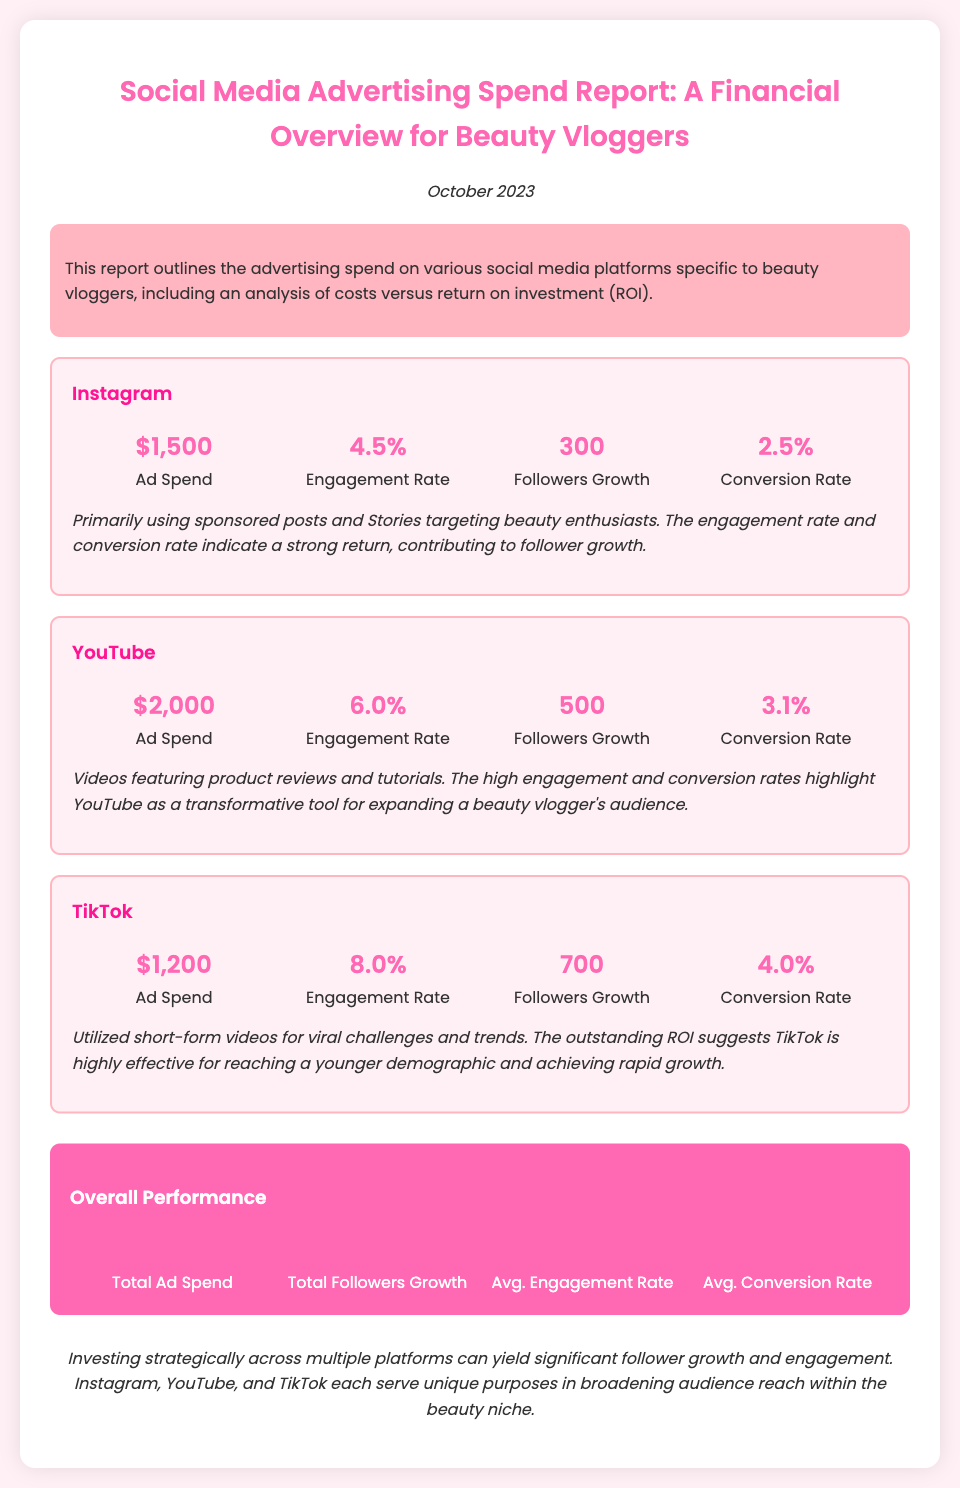What is the ad spend for Instagram? The ad spend for Instagram is explicitly stated in the document as $1,500.
Answer: $1,500 What is the engagement rate for TikTok? The engagement rate for TikTok is listed in the document as 8.0%.
Answer: 8.0% How much did YouTube ad spend total? The total ad spend for YouTube as mentioned in the report is $2,000.
Answer: $2,000 What is the total followers growth across all platforms? The total followers growth is summarized in the document as 1,500 across all platforms.
Answer: 1,500 What is the average conversion rate for all platforms? The document provides the average conversion rate as 3.20%.
Answer: 3.20% Which platform had the highest engagement rate? The highest engagement rate calculated from the data is for TikTok at 8.0%.
Answer: TikTok What was the primary method of advertisement on Instagram? The document notes that sponsored posts and Stories were the primary methods for Instagram.
Answer: Sponsored posts and Stories What conclusion is drawn about investing in multiple platforms? The document concludes that strategic investment across platforms yields significant benefits.
Answer: Significant follower growth and engagement What is the total ad spend across all platforms? The report summarizes the total ad spend as $4,700.
Answer: $4,700 